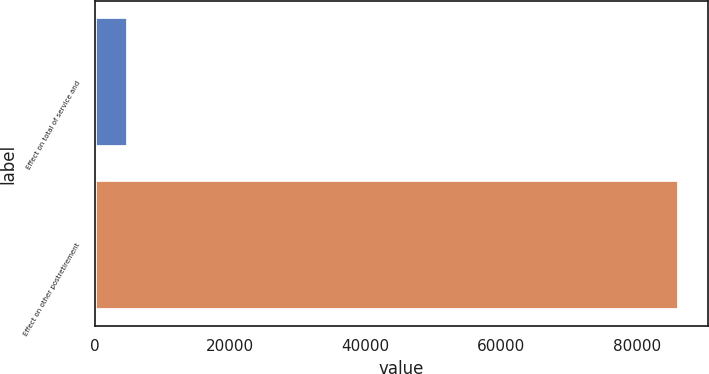Convert chart. <chart><loc_0><loc_0><loc_500><loc_500><bar_chart><fcel>Effect on total of service and<fcel>Effect on other postretirement<nl><fcel>4887<fcel>86179<nl></chart> 